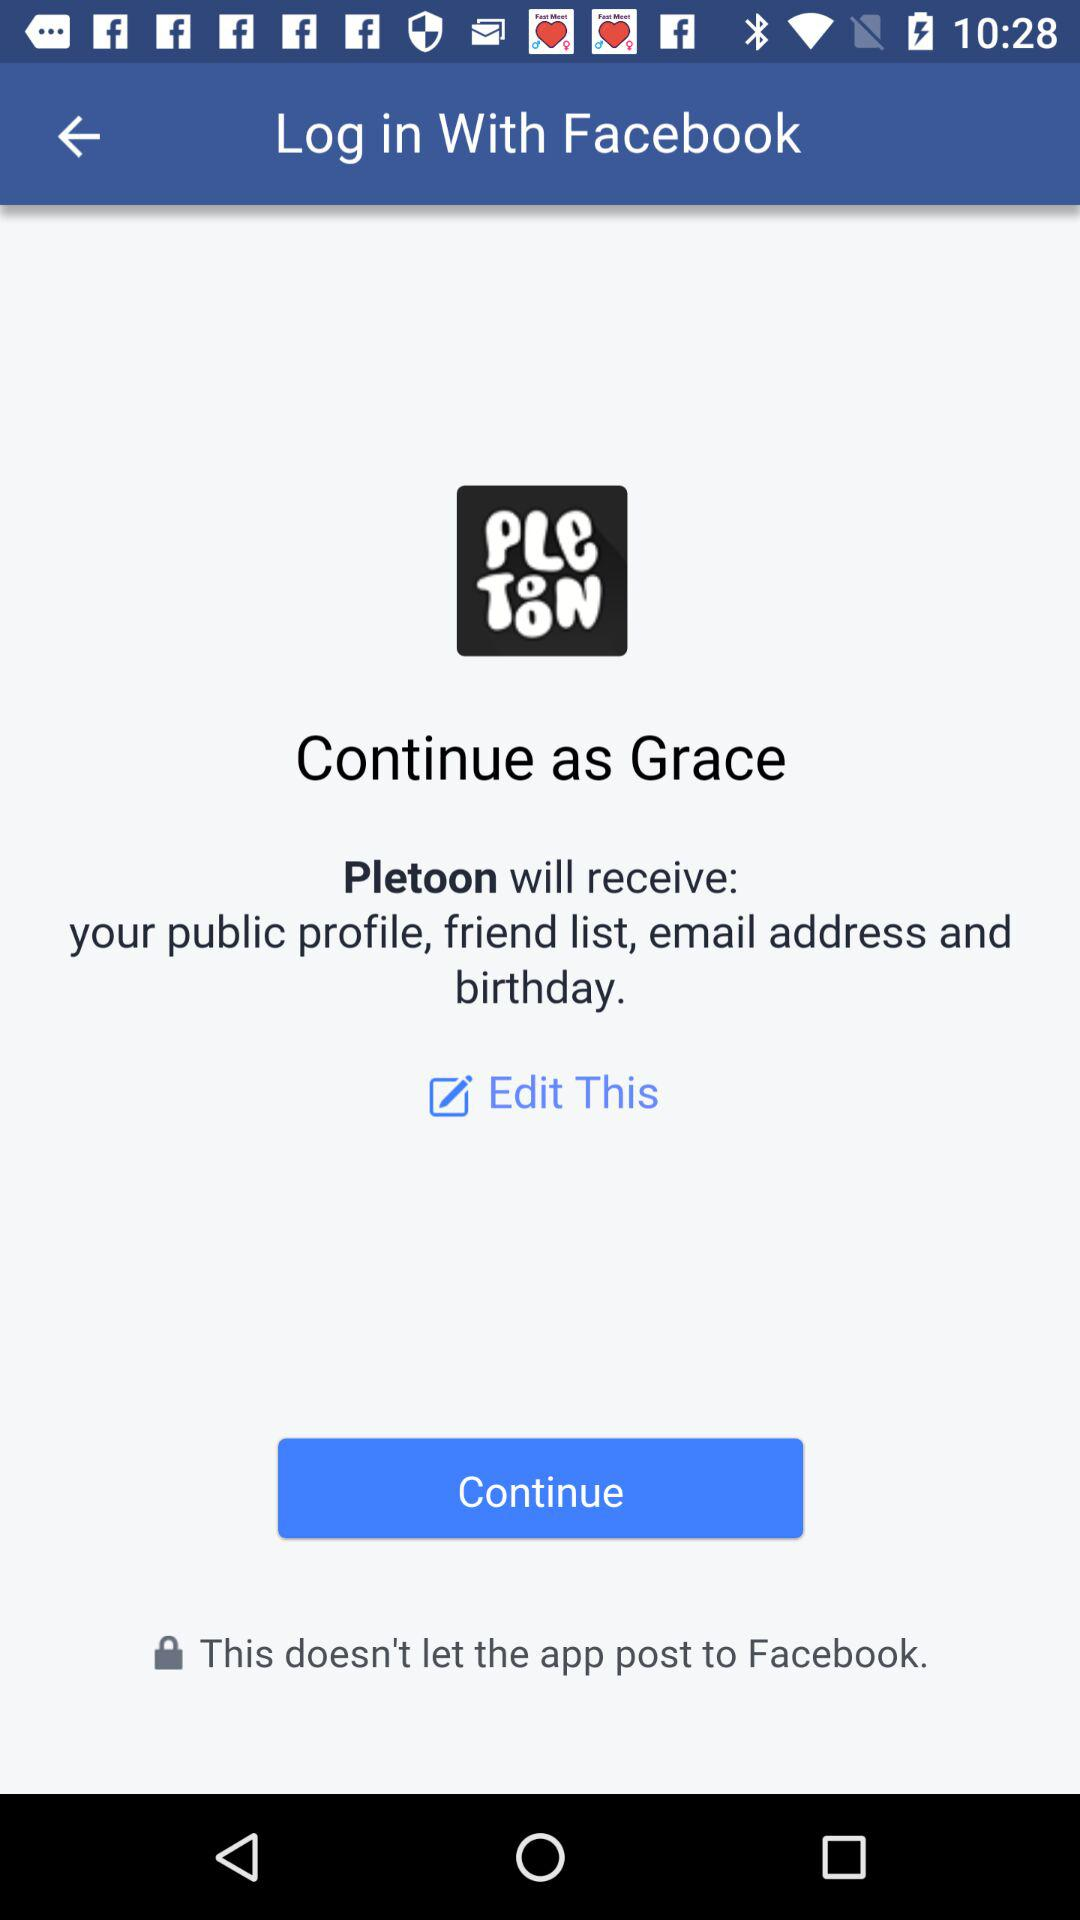What is the login name? The login name is Grace. 